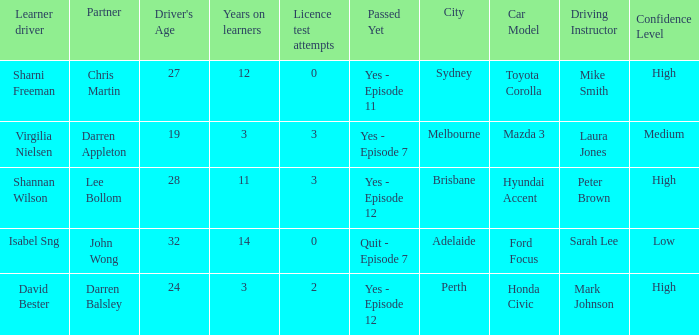What is the average number of years on learners of the drivers over the age of 24 with less than 0 attempts at the licence test? None. 